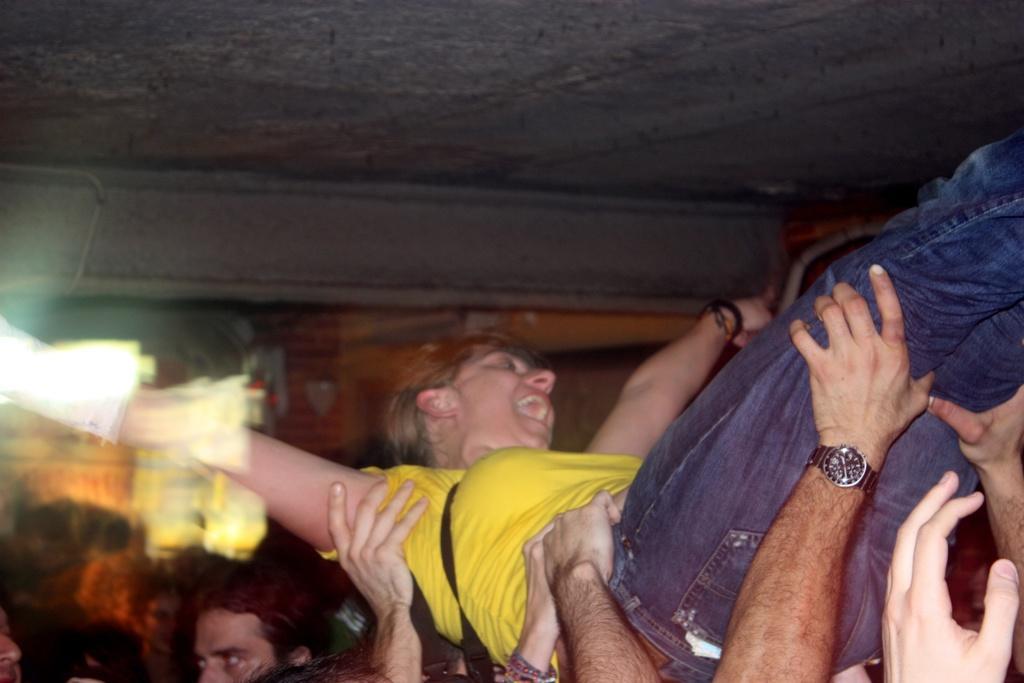Can you describe this image briefly? At the top we can see ceiling. Background is blurry. Here we can see wall with bricks. We can see all persons lifting one woman with their hands. She wore yellow shirt and blue denim jeans. This is a crowd. 